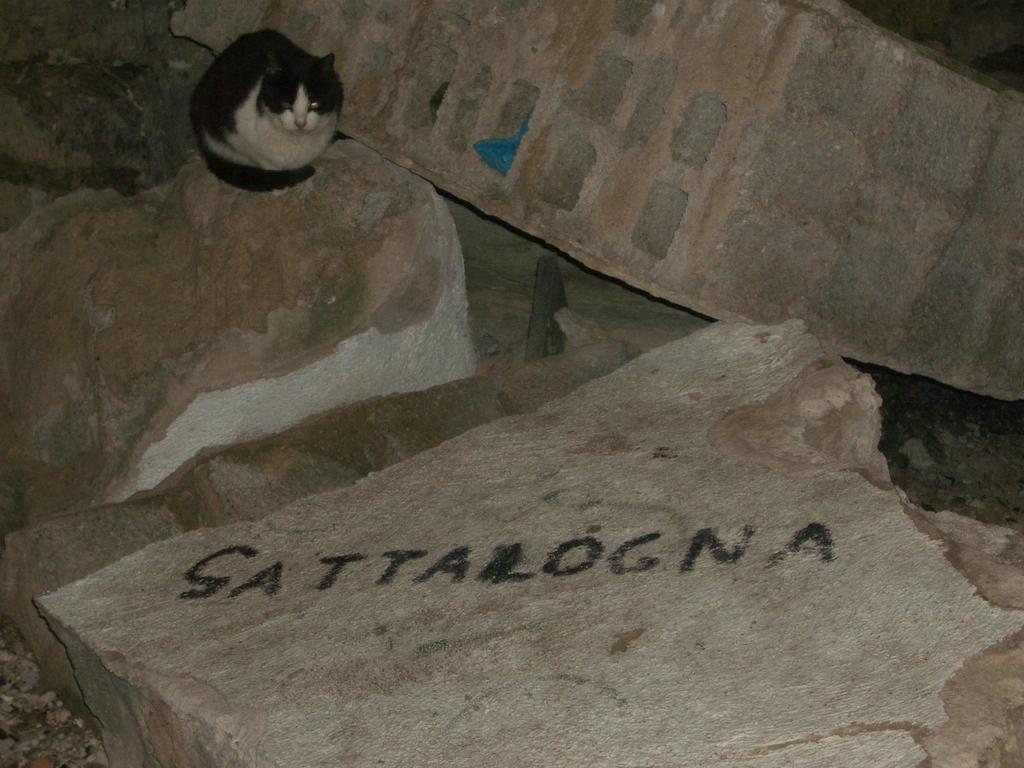Please provide a concise description of this image. In this picture I can see a cat on the rock, and there are rocks. 